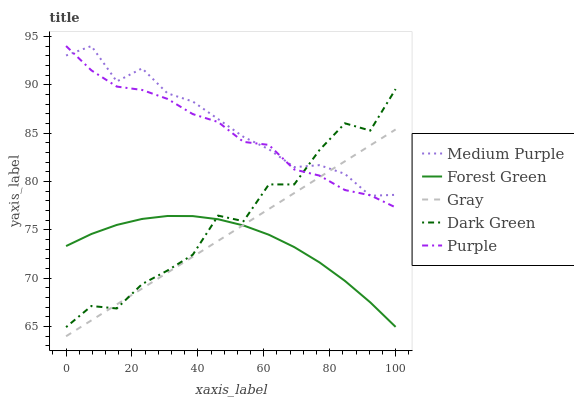Does Forest Green have the minimum area under the curve?
Answer yes or no. Yes. Does Medium Purple have the maximum area under the curve?
Answer yes or no. Yes. Does Gray have the minimum area under the curve?
Answer yes or no. No. Does Gray have the maximum area under the curve?
Answer yes or no. No. Is Gray the smoothest?
Answer yes or no. Yes. Is Dark Green the roughest?
Answer yes or no. Yes. Is Forest Green the smoothest?
Answer yes or no. No. Is Forest Green the roughest?
Answer yes or no. No. Does Gray have the lowest value?
Answer yes or no. Yes. Does Forest Green have the lowest value?
Answer yes or no. No. Does Purple have the highest value?
Answer yes or no. Yes. Does Gray have the highest value?
Answer yes or no. No. Is Forest Green less than Medium Purple?
Answer yes or no. Yes. Is Purple greater than Forest Green?
Answer yes or no. Yes. Does Forest Green intersect Dark Green?
Answer yes or no. Yes. Is Forest Green less than Dark Green?
Answer yes or no. No. Is Forest Green greater than Dark Green?
Answer yes or no. No. Does Forest Green intersect Medium Purple?
Answer yes or no. No. 